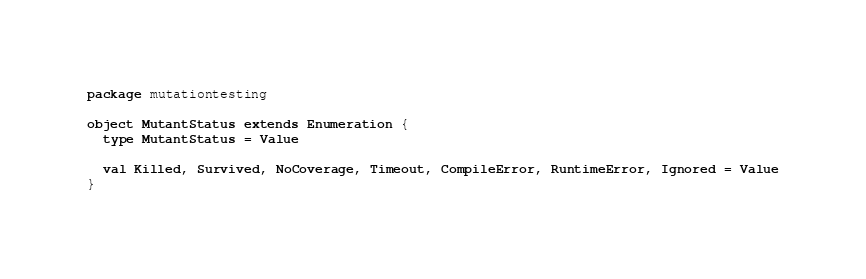<code> <loc_0><loc_0><loc_500><loc_500><_Scala_>package mutationtesting

object MutantStatus extends Enumeration {
  type MutantStatus = Value

  val Killed, Survived, NoCoverage, Timeout, CompileError, RuntimeError, Ignored = Value
}
</code> 